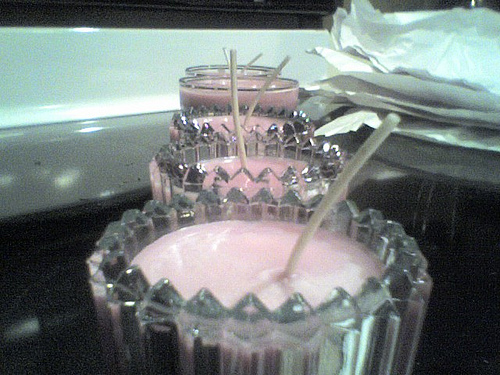<image>
Is the ice cream in front of the glass? No. The ice cream is not in front of the glass. The spatial positioning shows a different relationship between these objects. 